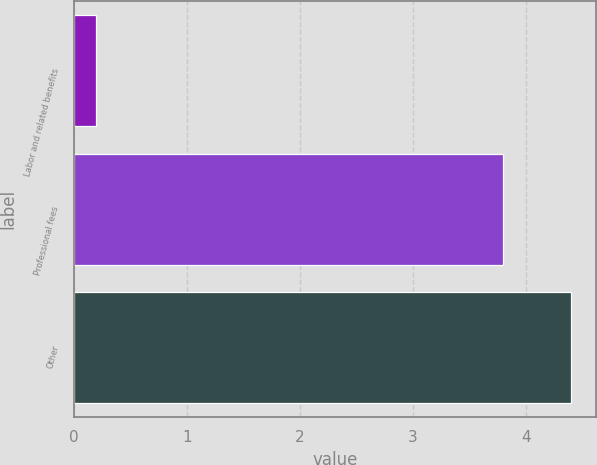<chart> <loc_0><loc_0><loc_500><loc_500><bar_chart><fcel>Labor and related benefits<fcel>Professional fees<fcel>Other<nl><fcel>0.2<fcel>3.8<fcel>4.4<nl></chart> 